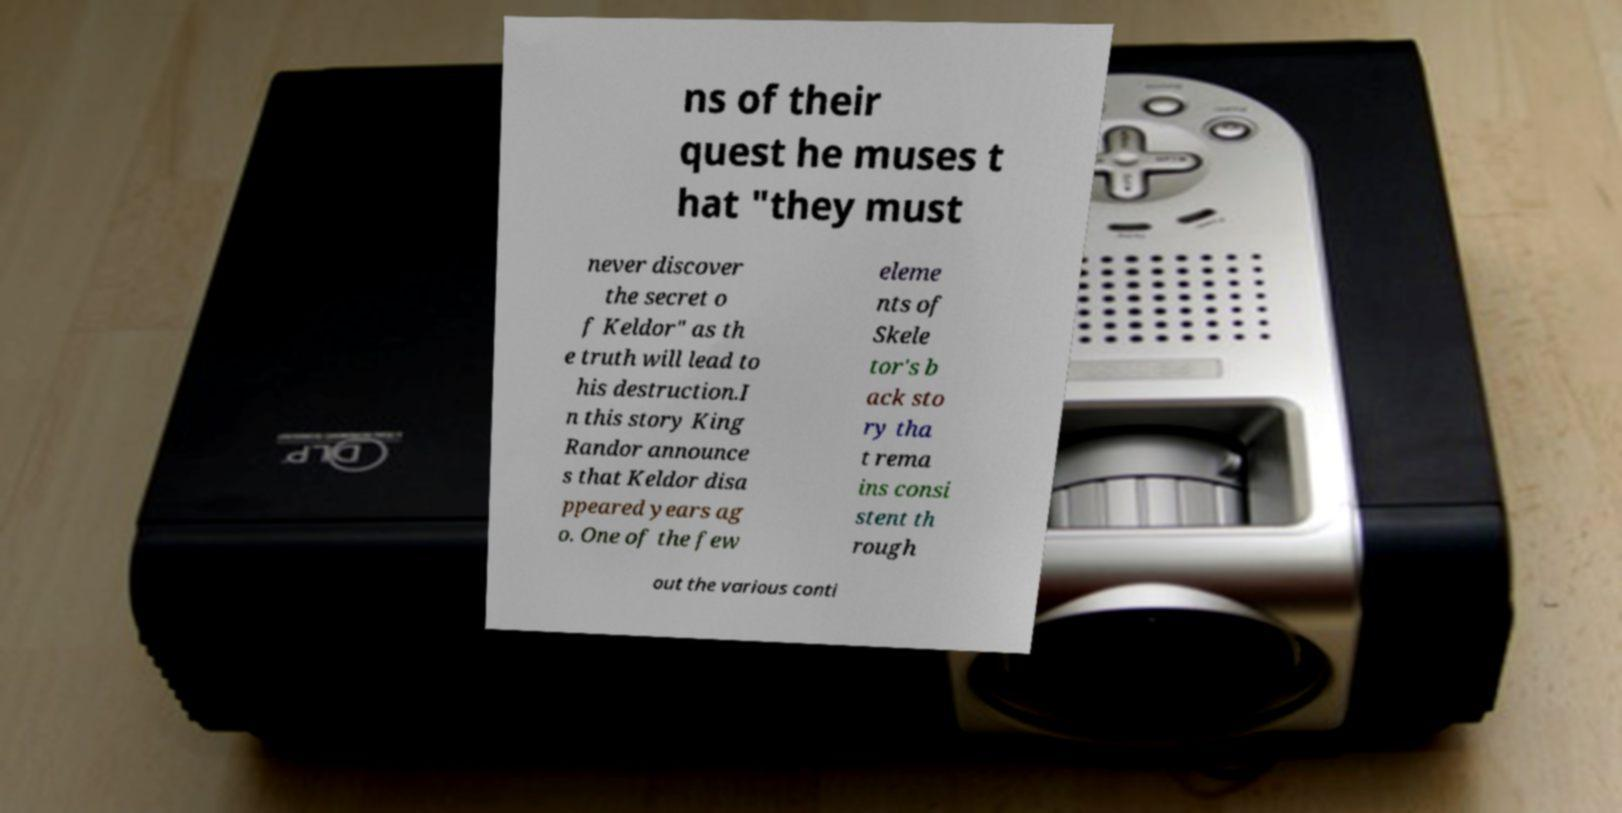Please identify and transcribe the text found in this image. ns of their quest he muses t hat "they must never discover the secret o f Keldor" as th e truth will lead to his destruction.I n this story King Randor announce s that Keldor disa ppeared years ag o. One of the few eleme nts of Skele tor's b ack sto ry tha t rema ins consi stent th rough out the various conti 